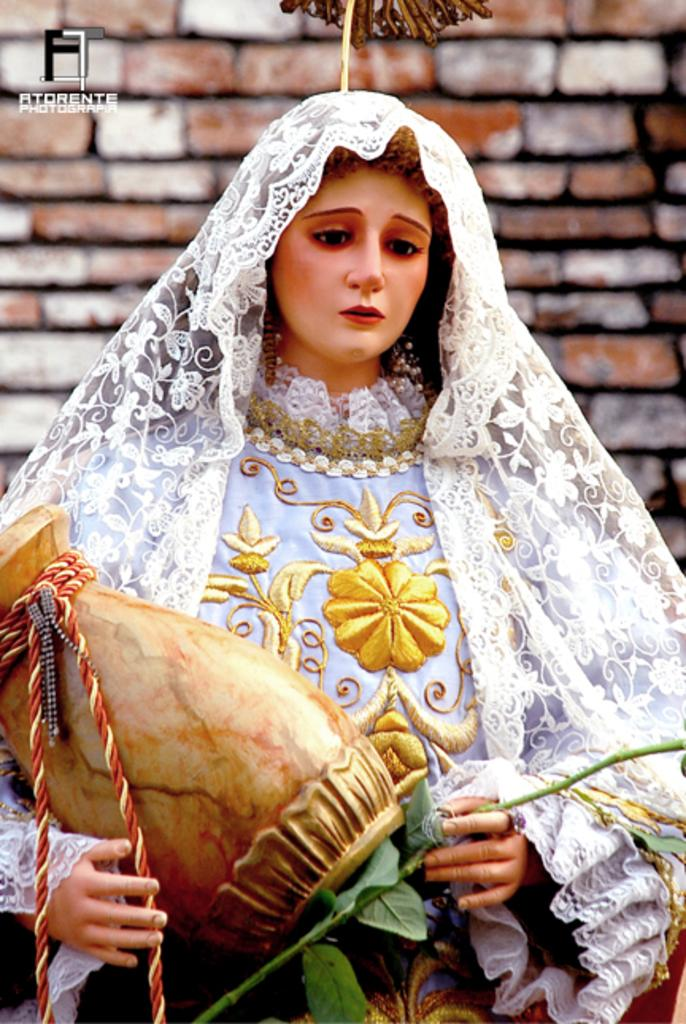What is the main subject of the image? There is a statue of a woman in the image. What is the woman holding in the image? The woman is holding a vase and the stem of a plant in the image. What can be seen in the background of the image? There is a wall visible in the image. Where is the aunt's camp located in the image? There is no aunt or camp present in the image; it features a statue of a woman holding a vase and the stem of a plant in front of a wall. 